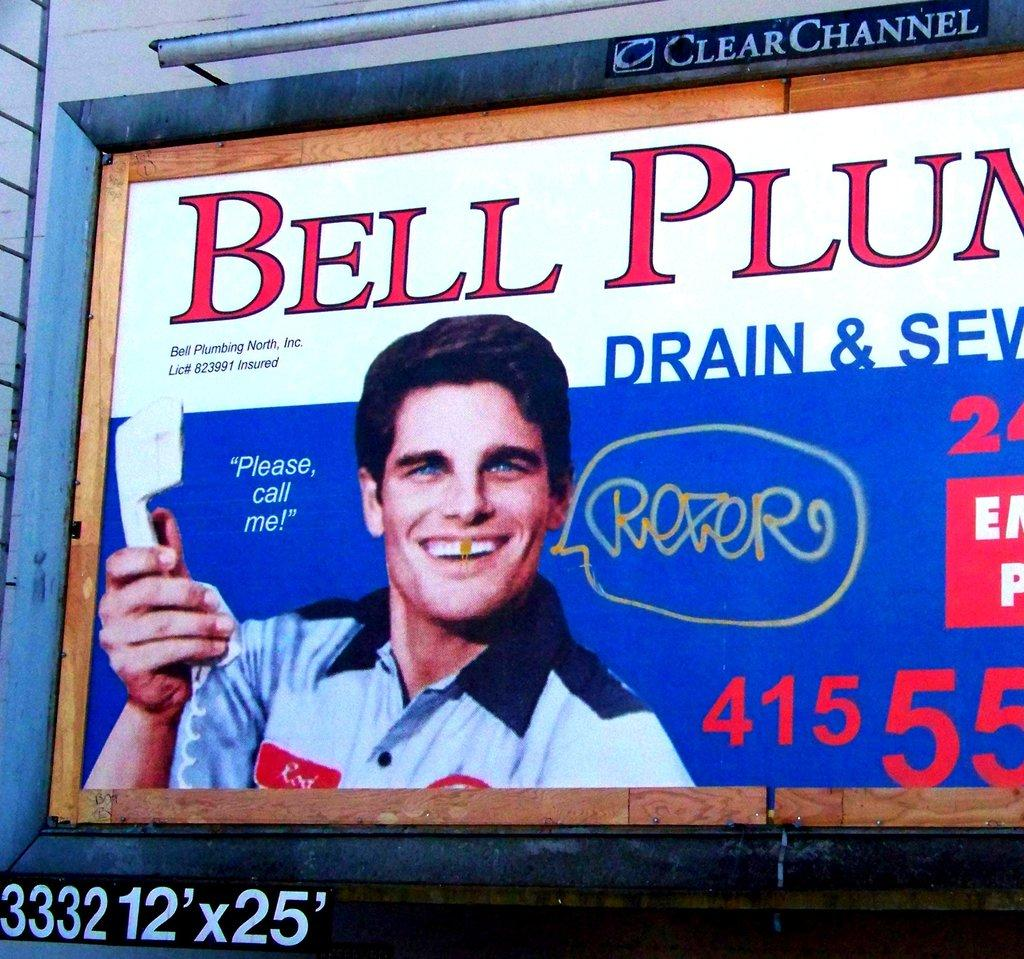<image>
Present a compact description of the photo's key features. A billboard advertising Bell Plumber, which has been partially defaced by vandalism. 